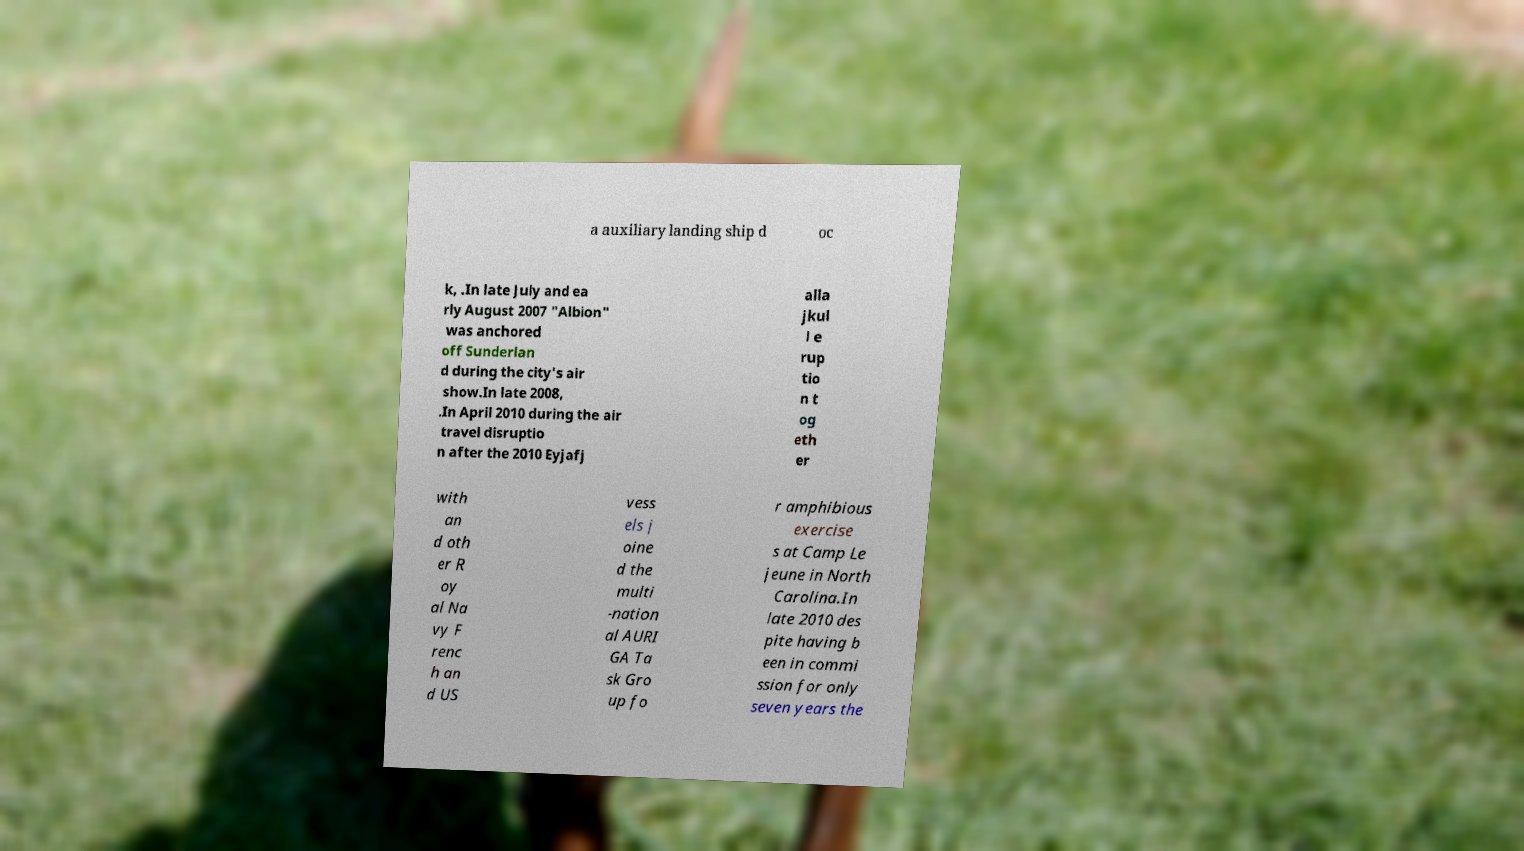Could you extract and type out the text from this image? a auxiliary landing ship d oc k, .In late July and ea rly August 2007 "Albion" was anchored off Sunderlan d during the city's air show.In late 2008, .In April 2010 during the air travel disruptio n after the 2010 Eyjafj alla jkul l e rup tio n t og eth er with an d oth er R oy al Na vy F renc h an d US vess els j oine d the multi -nation al AURI GA Ta sk Gro up fo r amphibious exercise s at Camp Le jeune in North Carolina.In late 2010 des pite having b een in commi ssion for only seven years the 